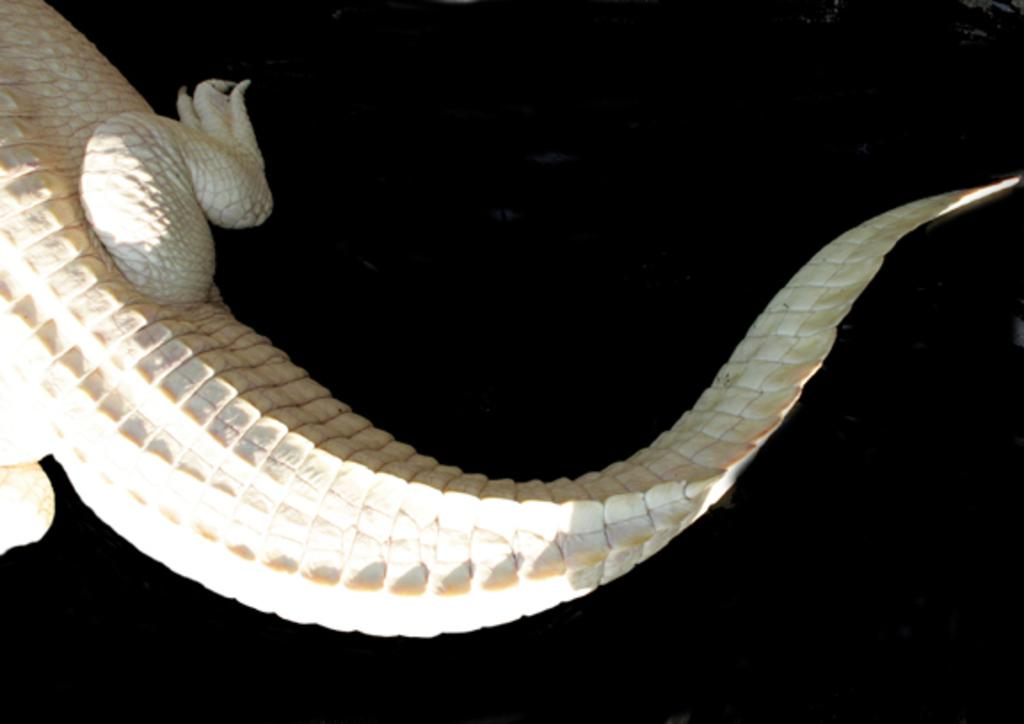What type of animal is in the image? There is a crocodile in the image. What type of bread is the crocodile holding in the image? There is no bread or any other food item present in the image; it features a crocodile. 